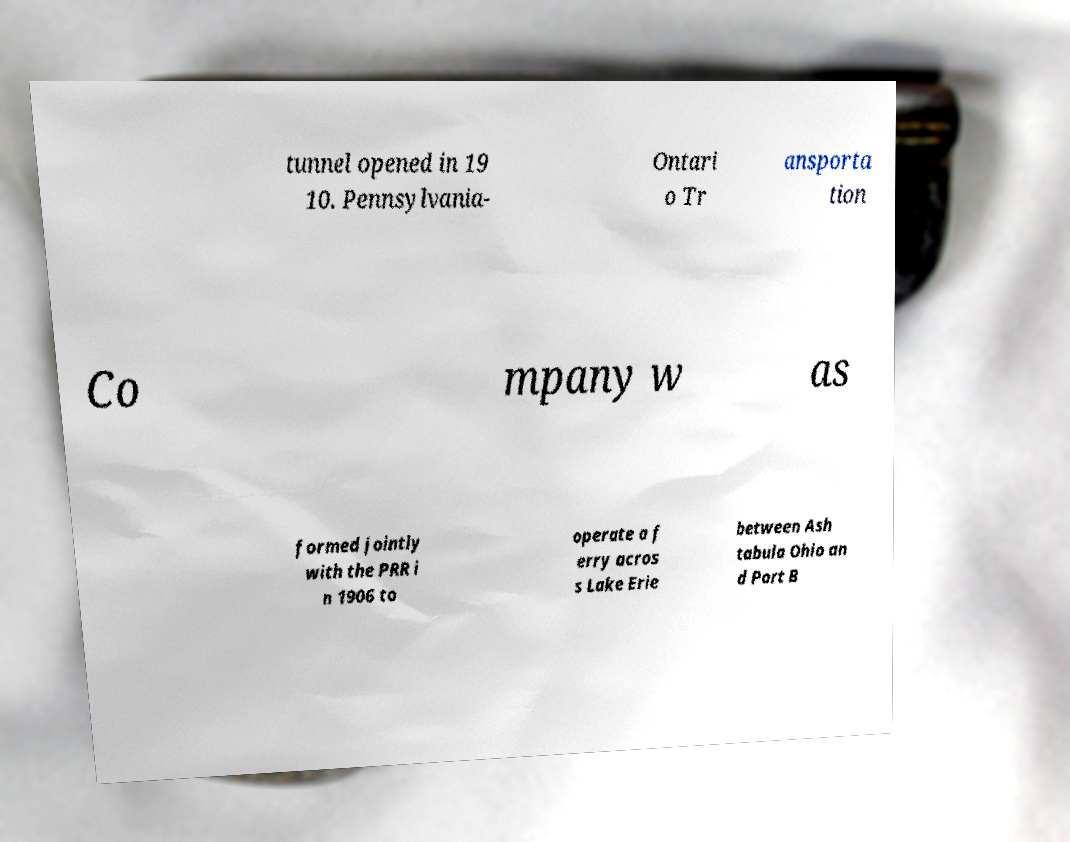Could you assist in decoding the text presented in this image and type it out clearly? tunnel opened in 19 10. Pennsylvania- Ontari o Tr ansporta tion Co mpany w as formed jointly with the PRR i n 1906 to operate a f erry acros s Lake Erie between Ash tabula Ohio an d Port B 